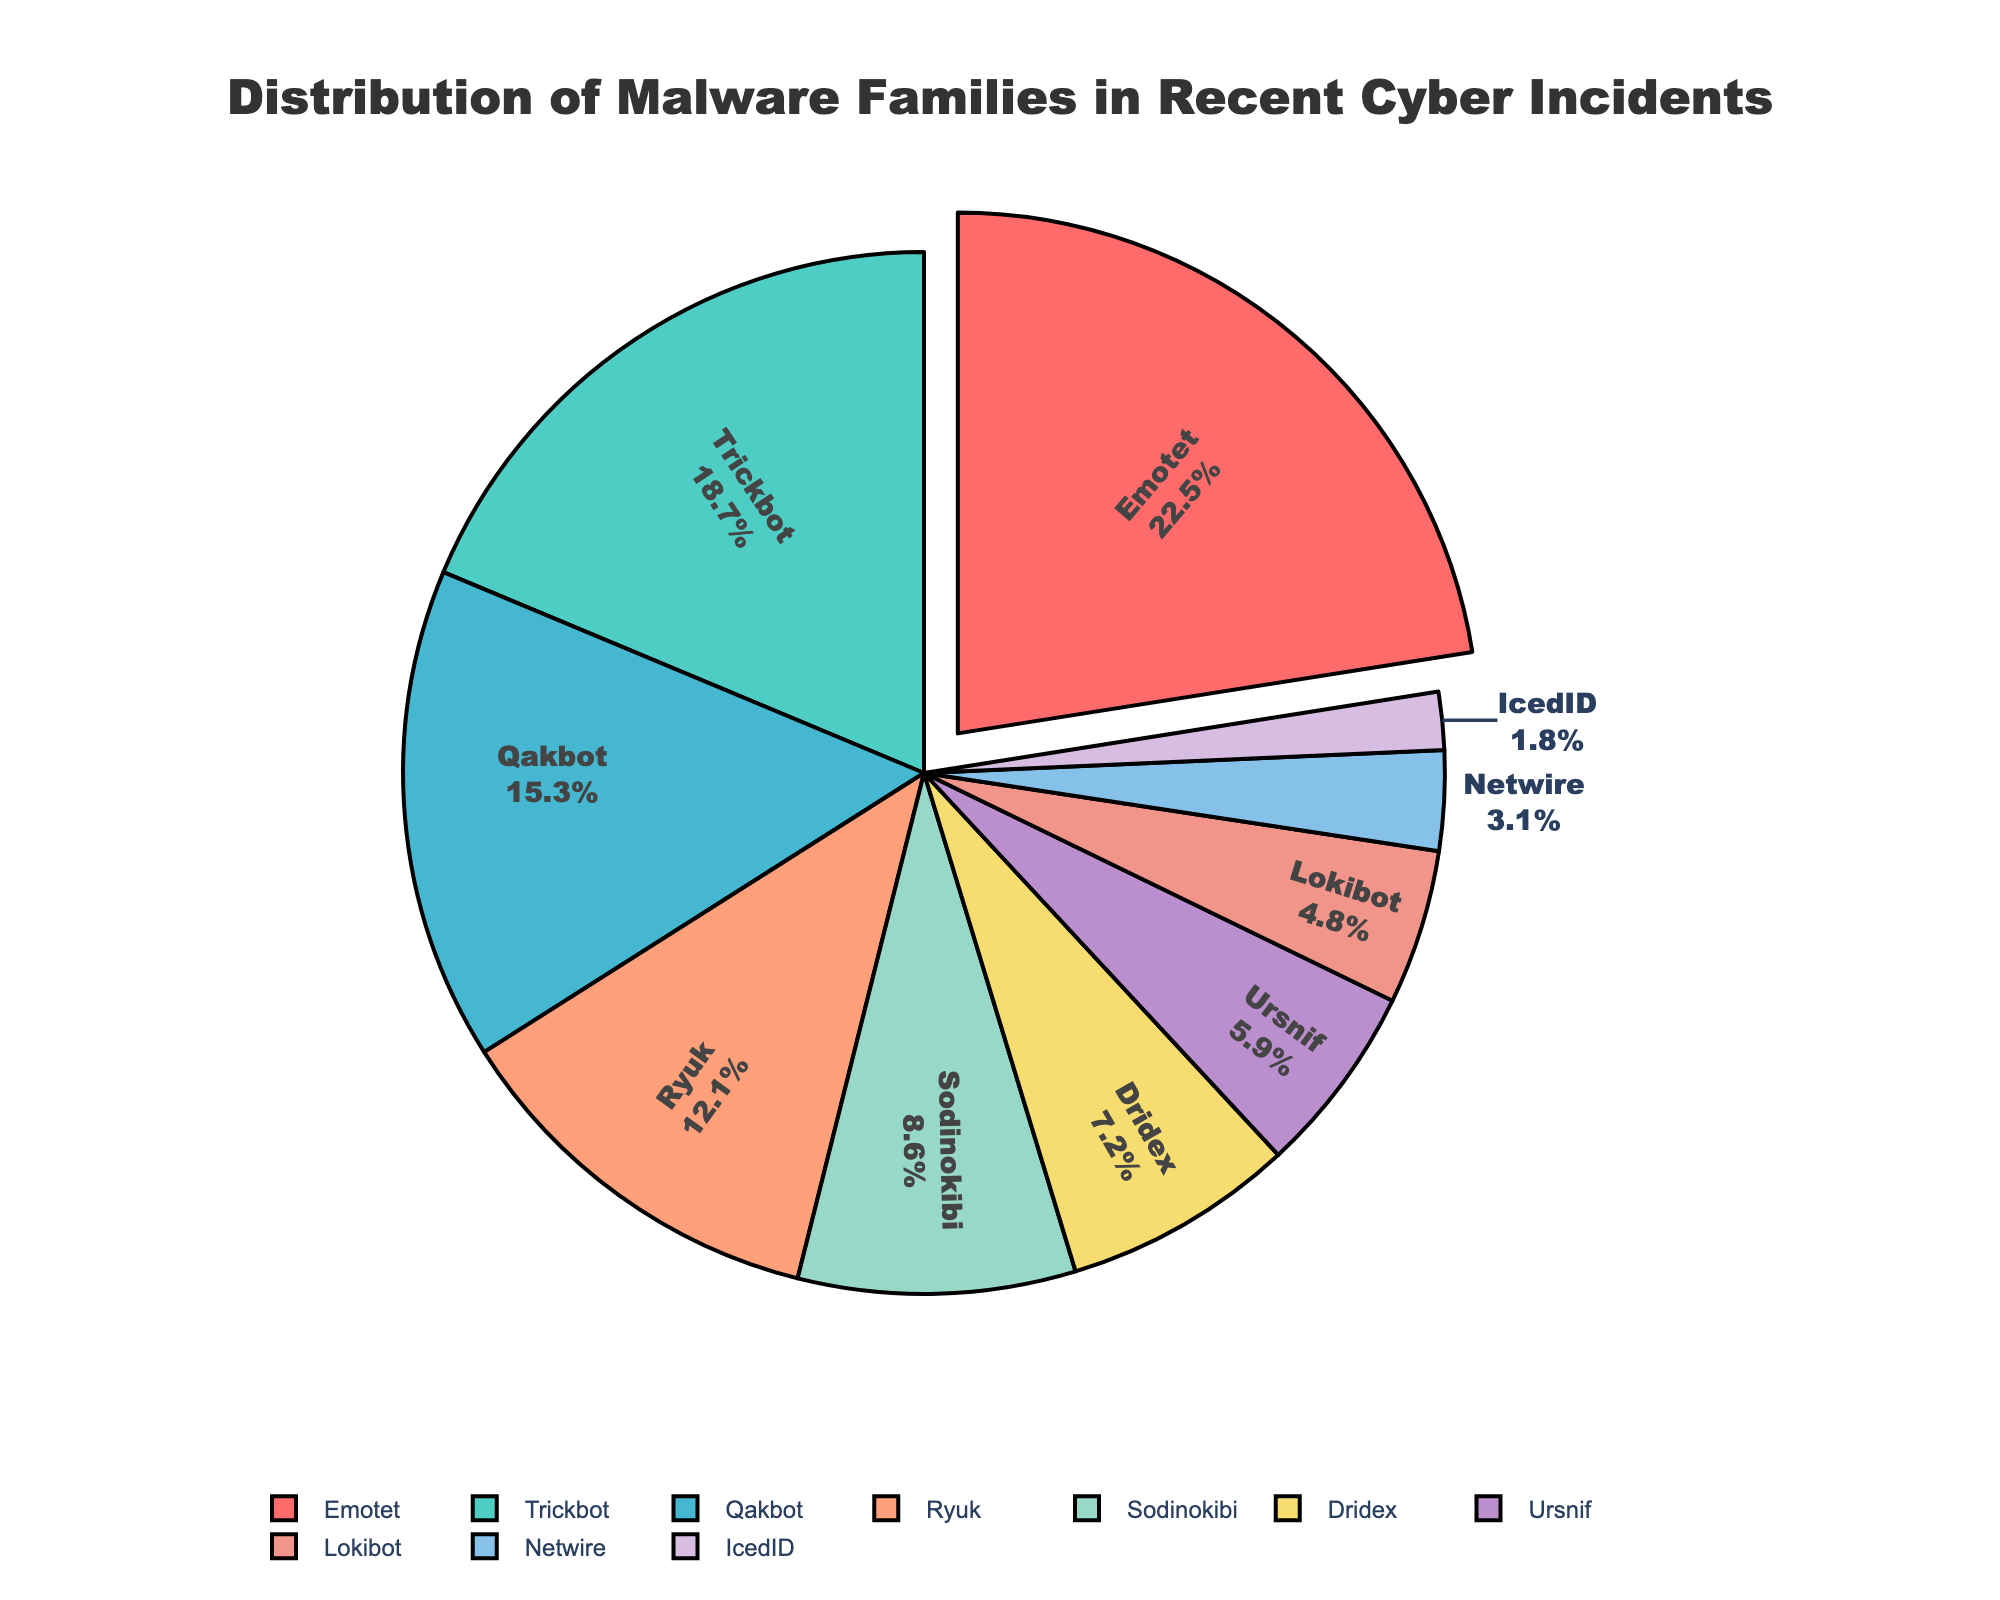What percentage of recent cyber incidents are attributed to Trickbot? Refer to the segment labeled as "Trickbot" and check its associated percentage, which is shown as part of the pie chart label.
Answer: 18.7% Which malware family accounts for the largest share of recent cyber incidents? Identify the segment with the largest percentage by comparing the labeled percentages in each segment of the pie chart.
Answer: Emotet What is the combined percentage of incidents attributed to Ryuk and Sodinokibi? Locate the segments labeled "Ryuk" and "Sodinokibi" on the chart. Add their percentages together (12.1% + 8.6%).
Answer: 20.7% How much more prevalent is Emotet compared to Ursnif? Find the percentage of Emotet and the percentage of Ursnif. Subtract the latter from the former (22.5% - 5.9%).
Answer: 16.6% List the malware families that collectively account for less than 10% of incidents each. Examine the chart to find segments with percentages less than 10%, which include IcedID, Netwire, Lokibot, Ursnif, and Dridex.
Answer: IcedID, Netwire, Lokibot, Ursnif, Dridex Which segment is highlighted (pulled out) in the pie chart? Observe the visual aspect of the chart and note the segment that is slightly separated from the rest, which is intended to draw attention.
Answer: Emotet Is the share of Qakbot incidents greater than the combined share of Lokibot and Netwire incidents? Compare the percentage of Qakbot (15.3%) with the sum of Lokibot and Netwire percentages (4.8% + 3.1% = 7.9%). Qakbot's percentage is higher.
Answer: Yes What is the difference between the percentage of incidents attributed to Trickbot and Qakbot? Subtract the percentage of Qakbot from Trickbot (18.7% - 15.3%).
Answer: 3.4% Which malware family with a blue sector accounts for 7.2% of incidents? Identify the sector with a blue color and corresponding label and percentage. This sector represents Dridex with 7.2%.
Answer: Dridex What is the average percentage of the top three most prevalent malware families? Identify the top three malware families: Emotet (22.5%), Trickbot (18.7%), and Qakbot (15.3%). Compute the average by summing their percentages and dividing by 3 ((22.5 + 18.7 + 15.3) / 3).
Answer: 18.83% 